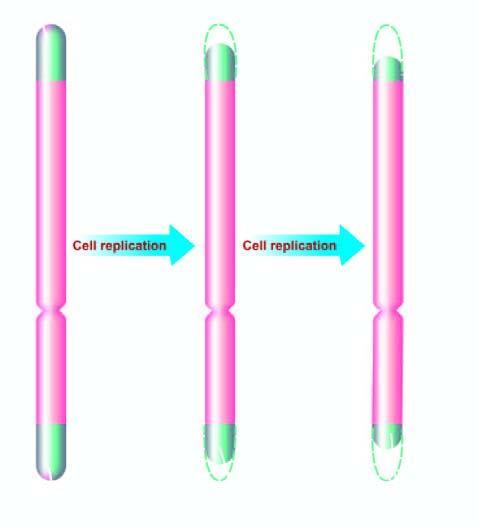re these end components of chromosome progressively shortened in aging?
Answer the question using a single word or phrase. Yes 